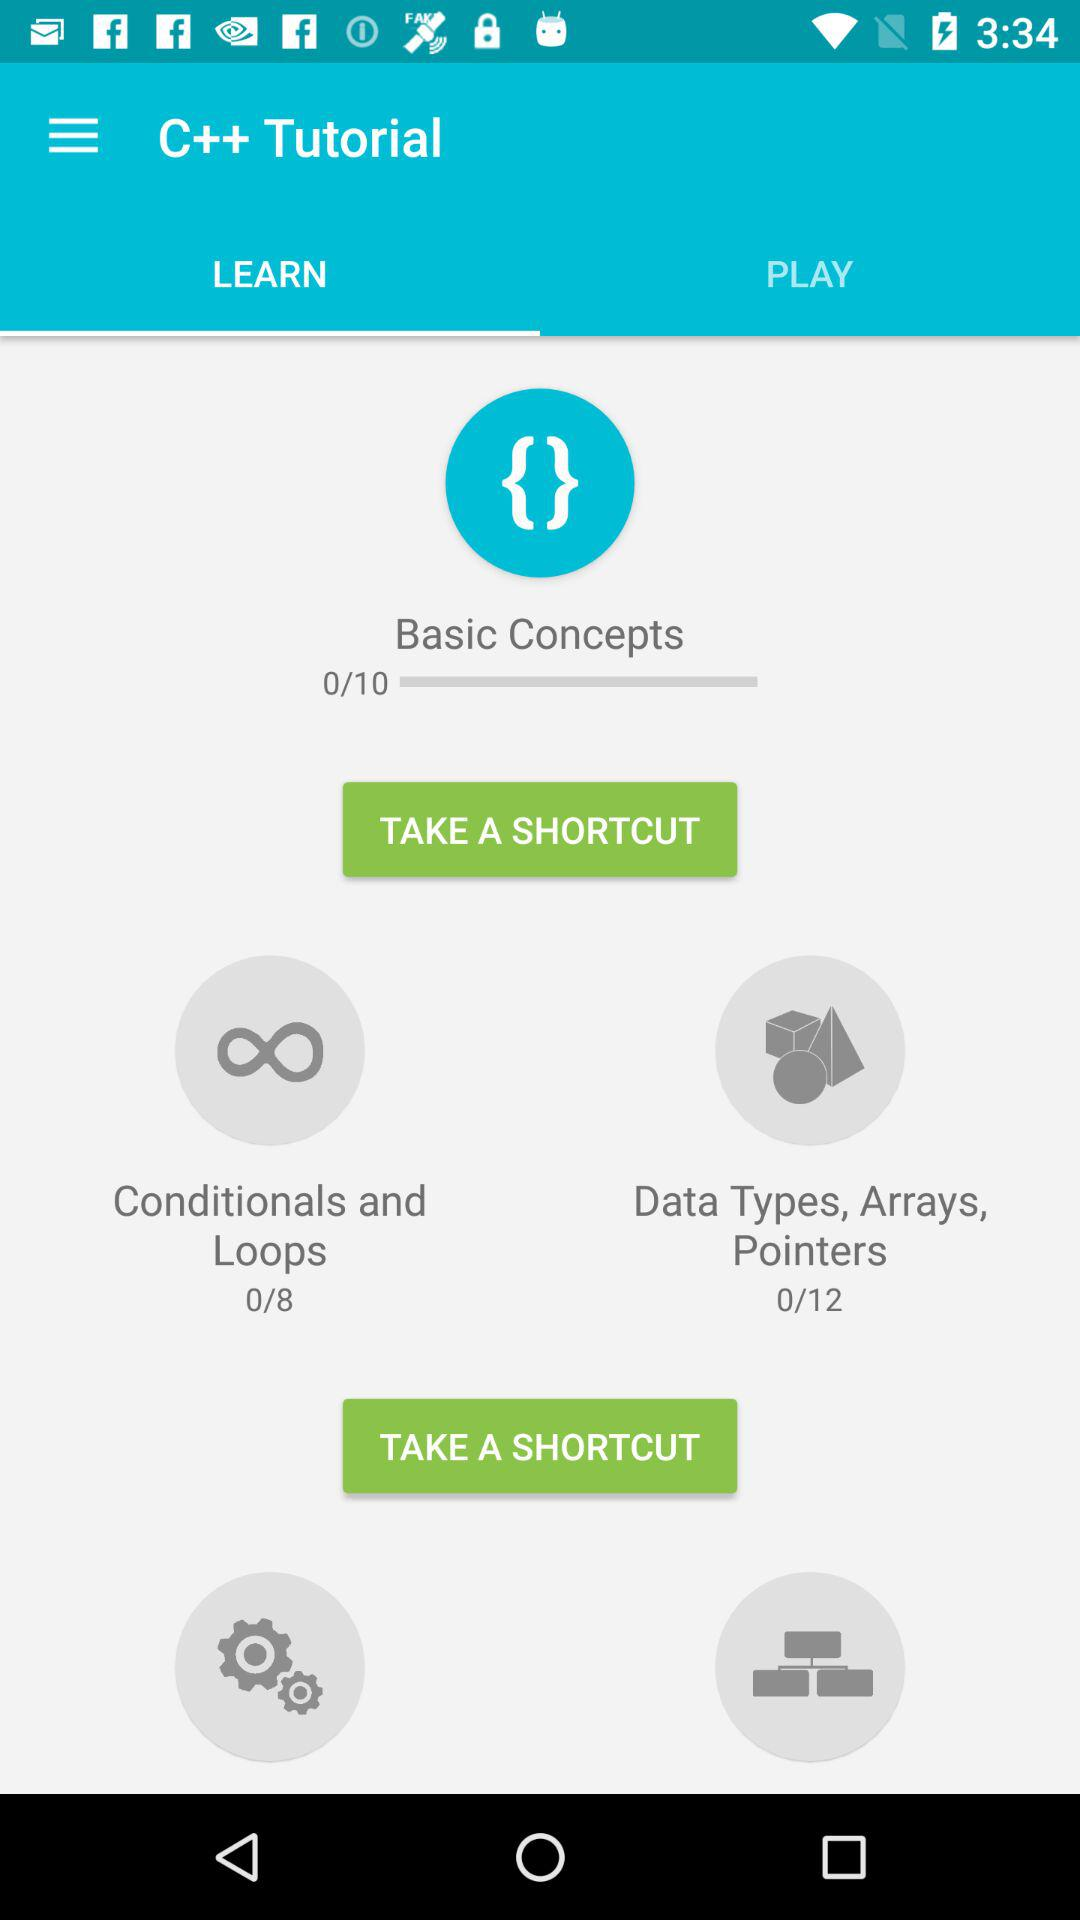How many stages are there in "Basic Concepts"? There are 10 stages. 